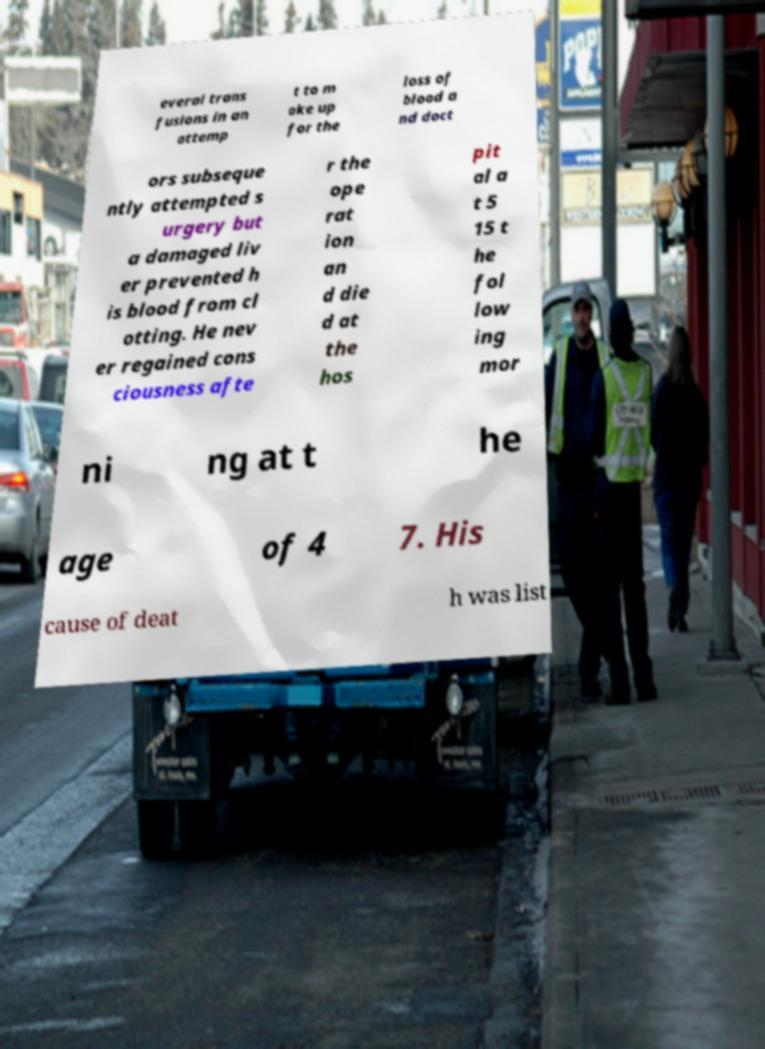Can you accurately transcribe the text from the provided image for me? everal trans fusions in an attemp t to m ake up for the loss of blood a nd doct ors subseque ntly attempted s urgery but a damaged liv er prevented h is blood from cl otting. He nev er regained cons ciousness afte r the ope rat ion an d die d at the hos pit al a t 5 15 t he fol low ing mor ni ng at t he age of 4 7. His cause of deat h was list 